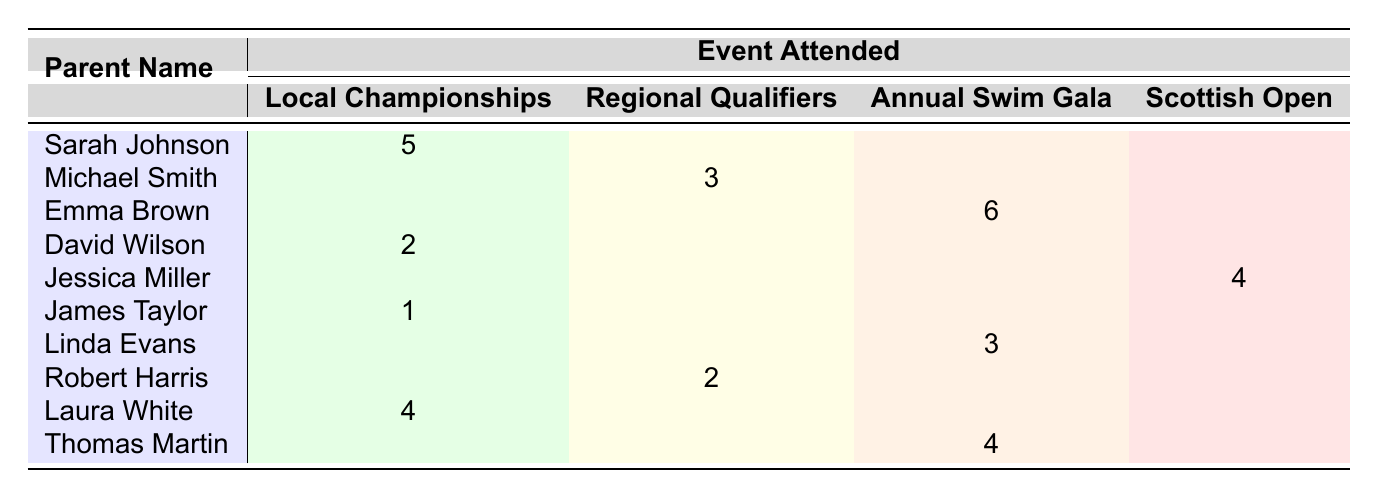What is the highest frequency of events attended by a parent? The table shows that Emma Brown attended the Annual Swim Gala with a frequency of 6, which is the highest among all parents.
Answer: 6 How many parents attended the Local Championships? Reviewing the table, we count the occurrences under the Local Championships column: Sarah Johnson (5), David Wilson (2), James Taylor (1), and Laura White (4), totaling 4 parents.
Answer: 4 Which event did Jessica Miller attend and how frequently? Looking at the table, Jessica Miller attended the Scottish Open with a frequency of 4.
Answer: Scottish Open, 4 Is it true that Linda Evans attended the Annual Swim Gala? The table shows Linda Evans has a frequency listed under the Annual Swim Gala, which confirms that it is true.
Answer: Yes What is the average frequency of attendance for the Regional Qualifiers? The frequencies for the Regional Qualifiers are from Michael Smith (3) and Robert Harris (2). To find the average, we sum these frequencies (3 + 2 = 5) and divide by the number of parents (2), resulting in an average frequency of 2.5.
Answer: 2.5 Which event had the most total attendance across all parents, and what was the total frequency? We sum the attendance for each event: Local Championships (5 + 2 + 1 + 4 = 12), Regional Qualifiers (3 + 2 = 5), Annual Swim Gala (6 + 3 + 4 = 13), and Scottish Open (4). The event with the highest total is the Annual Swim Gala with a total frequency of 13.
Answer: Annual Swim Gala, 13 How many events did David Wilson attend? According to the table, David Wilson only attended the Local Championships, so he attended 1 event.
Answer: 1 Did more parents attend the Annual Swim Gala compared to the Scottish Open? The Annual Swim Gala had 3 parents (Emma Brown, Linda Evans, Thomas Martin), while the Scottish Open had only 1 (Jessica Miller), confirming that more parents attended the Annual Swim Gala.
Answer: Yes 